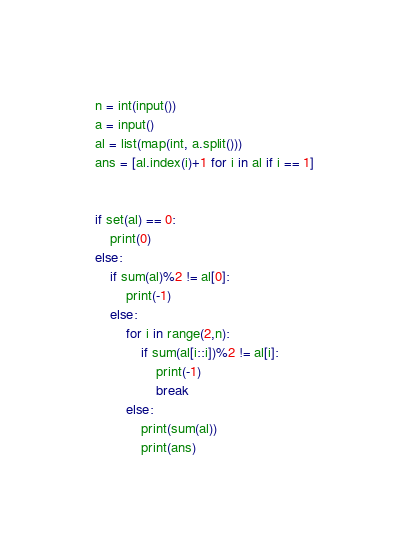Convert code to text. <code><loc_0><loc_0><loc_500><loc_500><_Python_>n = int(input())
a = input()
al = list(map(int, a.split()))
ans = [al.index(i)+1 for i in al if i == 1]


if set(al) == 0:
    print(0)
else:
    if sum(al)%2 != al[0]:
        print(-1)
    else:
        for i in range(2,n):
            if sum(al[i::i])%2 != al[i]:
                print(-1)
                break
        else:
            print(sum(al))
            print(ans)
</code> 